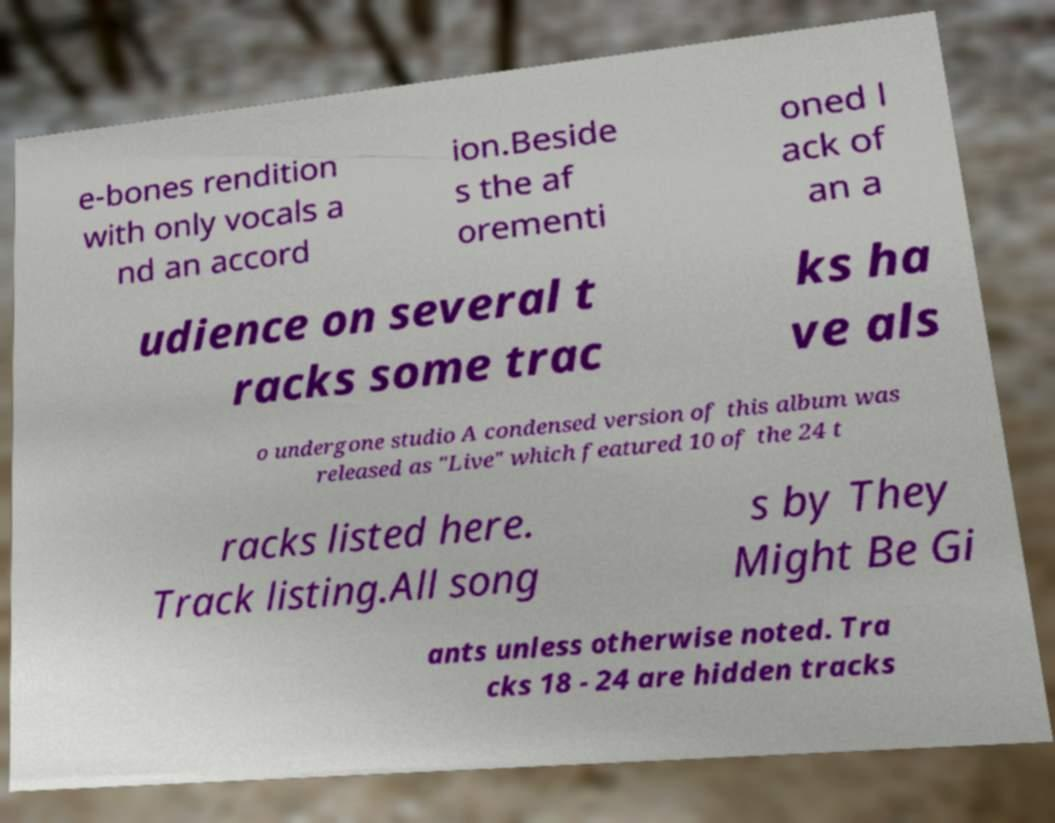Please identify and transcribe the text found in this image. e-bones rendition with only vocals a nd an accord ion.Beside s the af orementi oned l ack of an a udience on several t racks some trac ks ha ve als o undergone studio A condensed version of this album was released as "Live" which featured 10 of the 24 t racks listed here. Track listing.All song s by They Might Be Gi ants unless otherwise noted. Tra cks 18 - 24 are hidden tracks 